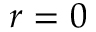Convert formula to latex. <formula><loc_0><loc_0><loc_500><loc_500>r = 0</formula> 